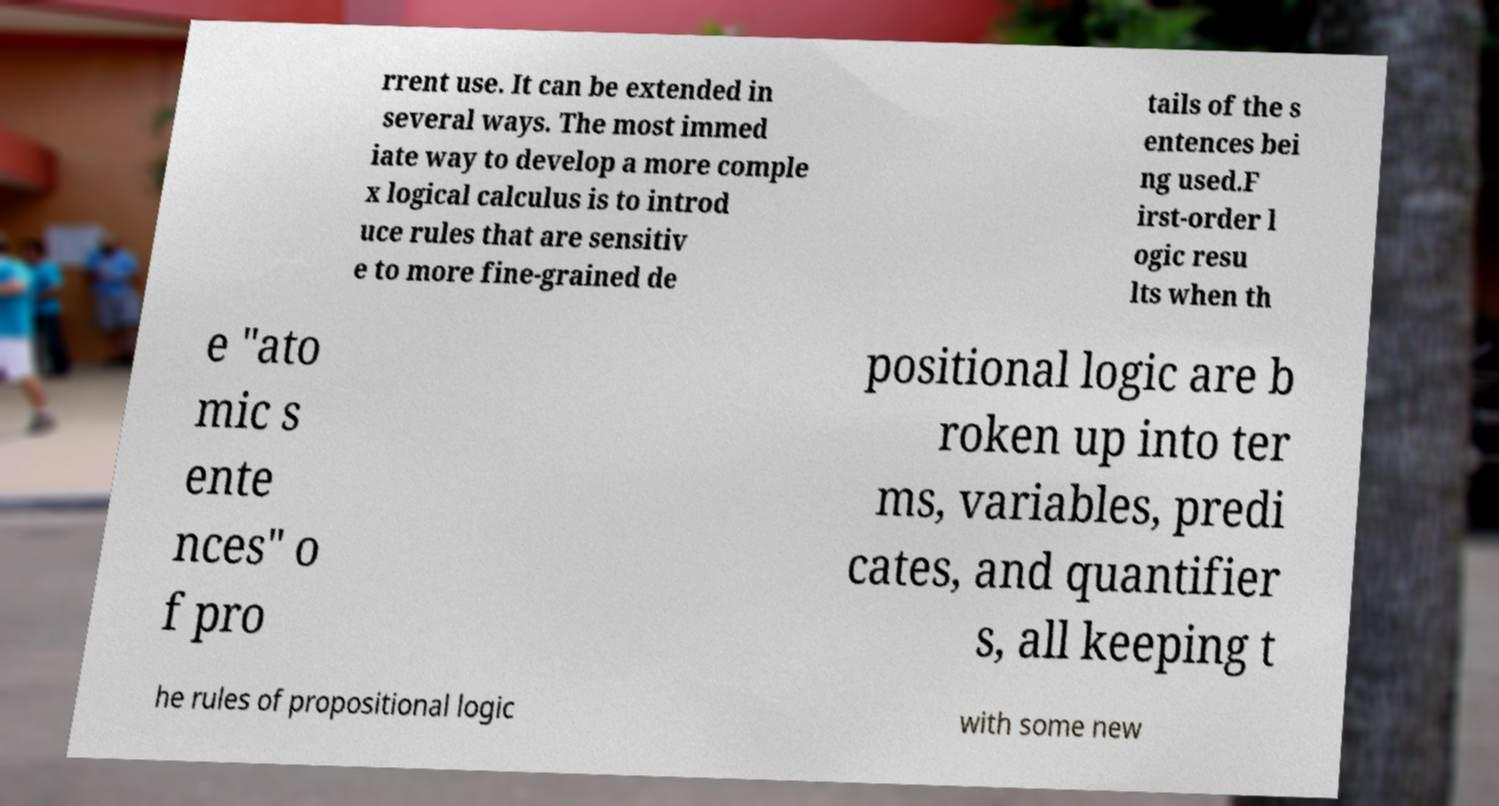Please read and relay the text visible in this image. What does it say? rrent use. It can be extended in several ways. The most immed iate way to develop a more comple x logical calculus is to introd uce rules that are sensitiv e to more fine-grained de tails of the s entences bei ng used.F irst-order l ogic resu lts when th e "ato mic s ente nces" o f pro positional logic are b roken up into ter ms, variables, predi cates, and quantifier s, all keeping t he rules of propositional logic with some new 